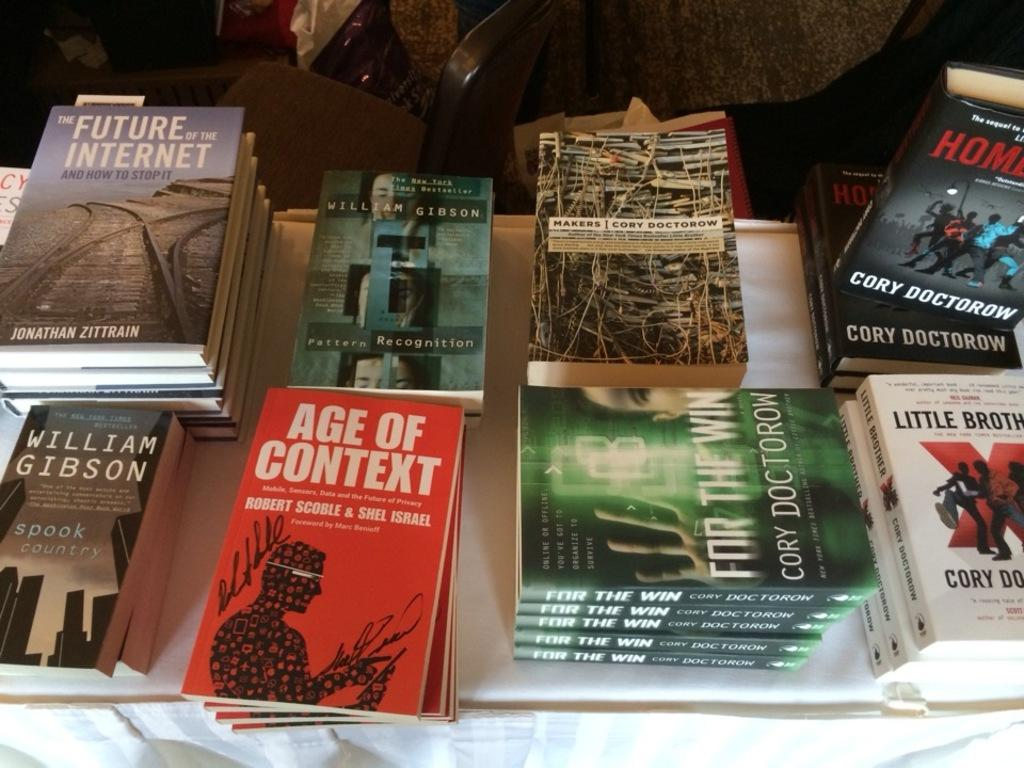<image>
Share a concise interpretation of the image provided. A number of nbooks stacked on a table including one called Age of Context and another by William Gibson. 